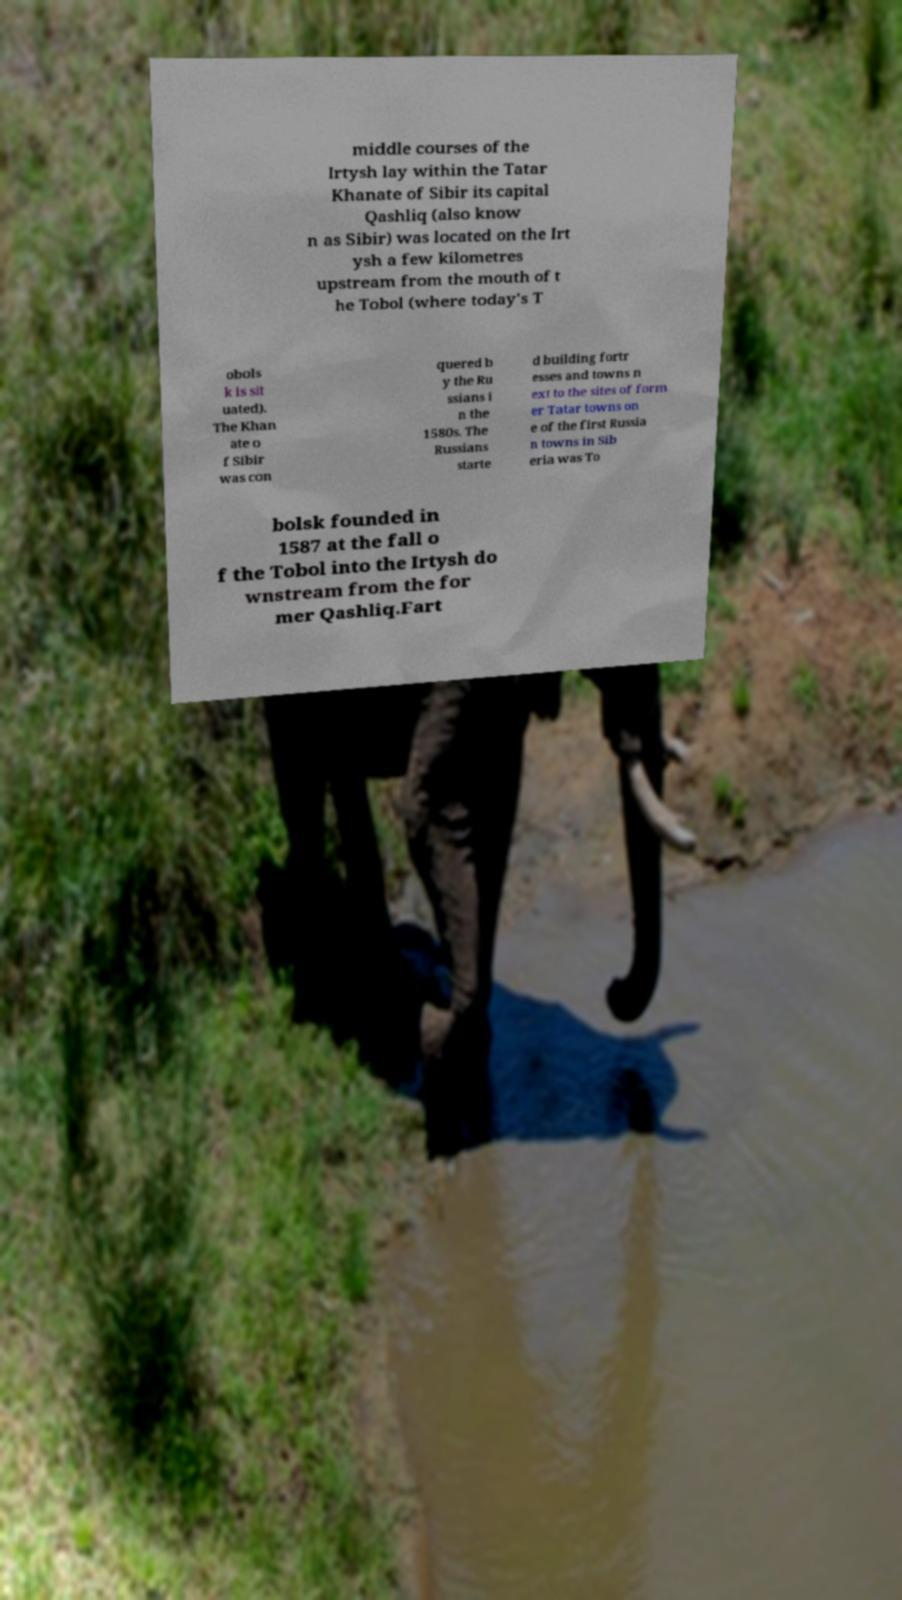There's text embedded in this image that I need extracted. Can you transcribe it verbatim? middle courses of the Irtysh lay within the Tatar Khanate of Sibir its capital Qashliq (also know n as Sibir) was located on the Irt ysh a few kilometres upstream from the mouth of t he Tobol (where today's T obols k is sit uated). The Khan ate o f Sibir was con quered b y the Ru ssians i n the 1580s. The Russians starte d building fortr esses and towns n ext to the sites of form er Tatar towns on e of the first Russia n towns in Sib eria was To bolsk founded in 1587 at the fall o f the Tobol into the Irtysh do wnstream from the for mer Qashliq.Fart 